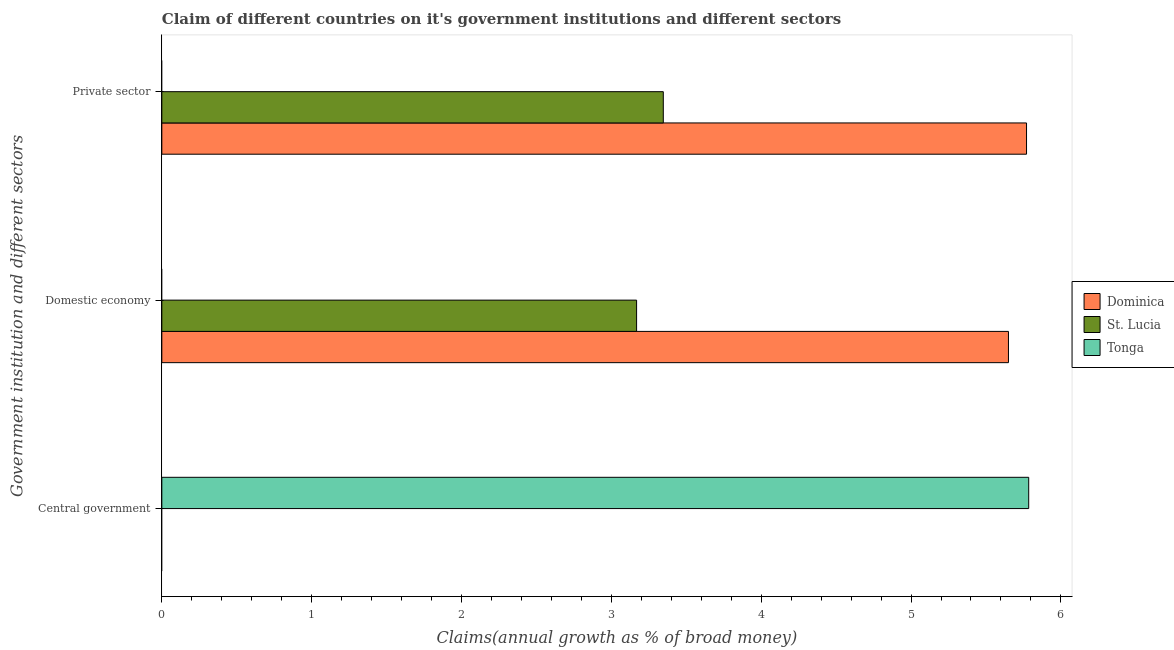Are the number of bars per tick equal to the number of legend labels?
Provide a short and direct response. No. How many bars are there on the 2nd tick from the top?
Your response must be concise. 2. How many bars are there on the 1st tick from the bottom?
Ensure brevity in your answer.  1. What is the label of the 1st group of bars from the top?
Make the answer very short. Private sector. What is the percentage of claim on the central government in Dominica?
Your response must be concise. 0. Across all countries, what is the maximum percentage of claim on the private sector?
Provide a short and direct response. 5.77. In which country was the percentage of claim on the private sector maximum?
Provide a succinct answer. Dominica. What is the total percentage of claim on the domestic economy in the graph?
Your response must be concise. 8.82. What is the difference between the percentage of claim on the domestic economy in Dominica and the percentage of claim on the central government in Tonga?
Offer a very short reply. -0.14. What is the average percentage of claim on the central government per country?
Make the answer very short. 1.93. What is the difference between the percentage of claim on the private sector and percentage of claim on the domestic economy in Dominica?
Offer a very short reply. 0.12. What is the ratio of the percentage of claim on the private sector in St. Lucia to that in Dominica?
Your answer should be very brief. 0.58. What is the difference between the highest and the lowest percentage of claim on the central government?
Your answer should be compact. 5.79. How many bars are there?
Provide a succinct answer. 5. How many countries are there in the graph?
Make the answer very short. 3. What is the difference between two consecutive major ticks on the X-axis?
Offer a terse response. 1. Does the graph contain any zero values?
Your answer should be compact. Yes. Does the graph contain grids?
Make the answer very short. No. Where does the legend appear in the graph?
Keep it short and to the point. Center right. What is the title of the graph?
Keep it short and to the point. Claim of different countries on it's government institutions and different sectors. Does "French Polynesia" appear as one of the legend labels in the graph?
Provide a succinct answer. No. What is the label or title of the X-axis?
Offer a terse response. Claims(annual growth as % of broad money). What is the label or title of the Y-axis?
Make the answer very short. Government institution and different sectors. What is the Claims(annual growth as % of broad money) in Dominica in Central government?
Ensure brevity in your answer.  0. What is the Claims(annual growth as % of broad money) in St. Lucia in Central government?
Your answer should be compact. 0. What is the Claims(annual growth as % of broad money) of Tonga in Central government?
Make the answer very short. 5.79. What is the Claims(annual growth as % of broad money) of Dominica in Domestic economy?
Provide a short and direct response. 5.65. What is the Claims(annual growth as % of broad money) in St. Lucia in Domestic economy?
Give a very brief answer. 3.17. What is the Claims(annual growth as % of broad money) in Dominica in Private sector?
Your answer should be very brief. 5.77. What is the Claims(annual growth as % of broad money) in St. Lucia in Private sector?
Offer a very short reply. 3.35. What is the Claims(annual growth as % of broad money) of Tonga in Private sector?
Your answer should be very brief. 0. Across all Government institution and different sectors, what is the maximum Claims(annual growth as % of broad money) of Dominica?
Ensure brevity in your answer.  5.77. Across all Government institution and different sectors, what is the maximum Claims(annual growth as % of broad money) in St. Lucia?
Provide a succinct answer. 3.35. Across all Government institution and different sectors, what is the maximum Claims(annual growth as % of broad money) of Tonga?
Your response must be concise. 5.79. Across all Government institution and different sectors, what is the minimum Claims(annual growth as % of broad money) in St. Lucia?
Your answer should be compact. 0. Across all Government institution and different sectors, what is the minimum Claims(annual growth as % of broad money) in Tonga?
Your answer should be very brief. 0. What is the total Claims(annual growth as % of broad money) of Dominica in the graph?
Offer a very short reply. 11.42. What is the total Claims(annual growth as % of broad money) of St. Lucia in the graph?
Give a very brief answer. 6.52. What is the total Claims(annual growth as % of broad money) of Tonga in the graph?
Offer a terse response. 5.79. What is the difference between the Claims(annual growth as % of broad money) of Dominica in Domestic economy and that in Private sector?
Offer a very short reply. -0.12. What is the difference between the Claims(annual growth as % of broad money) in St. Lucia in Domestic economy and that in Private sector?
Ensure brevity in your answer.  -0.18. What is the difference between the Claims(annual growth as % of broad money) in Dominica in Domestic economy and the Claims(annual growth as % of broad money) in St. Lucia in Private sector?
Provide a short and direct response. 2.3. What is the average Claims(annual growth as % of broad money) in Dominica per Government institution and different sectors?
Your answer should be compact. 3.81. What is the average Claims(annual growth as % of broad money) of St. Lucia per Government institution and different sectors?
Provide a short and direct response. 2.17. What is the average Claims(annual growth as % of broad money) in Tonga per Government institution and different sectors?
Offer a terse response. 1.93. What is the difference between the Claims(annual growth as % of broad money) of Dominica and Claims(annual growth as % of broad money) of St. Lucia in Domestic economy?
Ensure brevity in your answer.  2.48. What is the difference between the Claims(annual growth as % of broad money) in Dominica and Claims(annual growth as % of broad money) in St. Lucia in Private sector?
Make the answer very short. 2.42. What is the ratio of the Claims(annual growth as % of broad money) of Dominica in Domestic economy to that in Private sector?
Your answer should be very brief. 0.98. What is the ratio of the Claims(annual growth as % of broad money) in St. Lucia in Domestic economy to that in Private sector?
Keep it short and to the point. 0.95. What is the difference between the highest and the lowest Claims(annual growth as % of broad money) of Dominica?
Ensure brevity in your answer.  5.77. What is the difference between the highest and the lowest Claims(annual growth as % of broad money) in St. Lucia?
Ensure brevity in your answer.  3.35. What is the difference between the highest and the lowest Claims(annual growth as % of broad money) in Tonga?
Offer a very short reply. 5.79. 